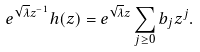Convert formula to latex. <formula><loc_0><loc_0><loc_500><loc_500>e ^ { \sqrt { \lambda } z ^ { - 1 } } h ( z ) = e ^ { \sqrt { \lambda } z } \sum _ { j \geq 0 } b _ { j } z ^ { j } .</formula> 